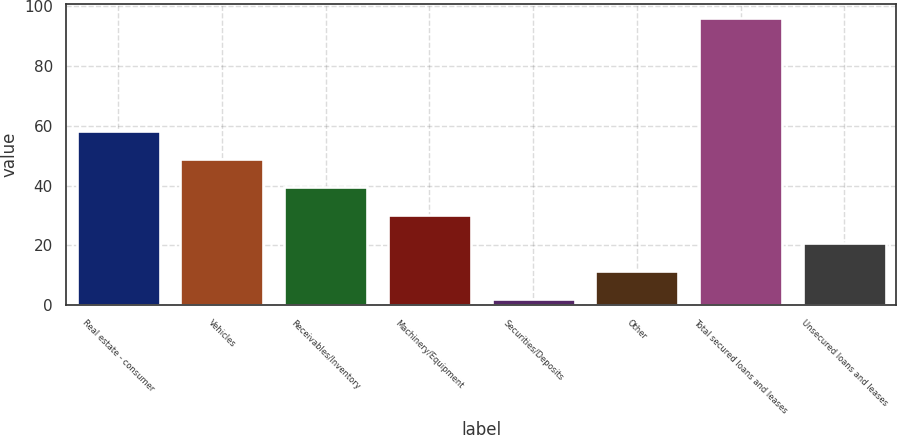Convert chart to OTSL. <chart><loc_0><loc_0><loc_500><loc_500><bar_chart><fcel>Real estate - consumer<fcel>Vehicles<fcel>Receivables/Inventory<fcel>Machinery/Equipment<fcel>Securities/Deposits<fcel>Other<fcel>Total secured loans and leases<fcel>Unsecured loans and leases<nl><fcel>58.4<fcel>49<fcel>39.6<fcel>30.2<fcel>2<fcel>11.4<fcel>96<fcel>20.8<nl></chart> 